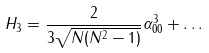Convert formula to latex. <formula><loc_0><loc_0><loc_500><loc_500>H _ { 3 } = { \frac { 2 } { 3 \sqrt { N ( N ^ { 2 } - 1 ) } } } \alpha _ { 0 0 } ^ { 3 } + \dots</formula> 